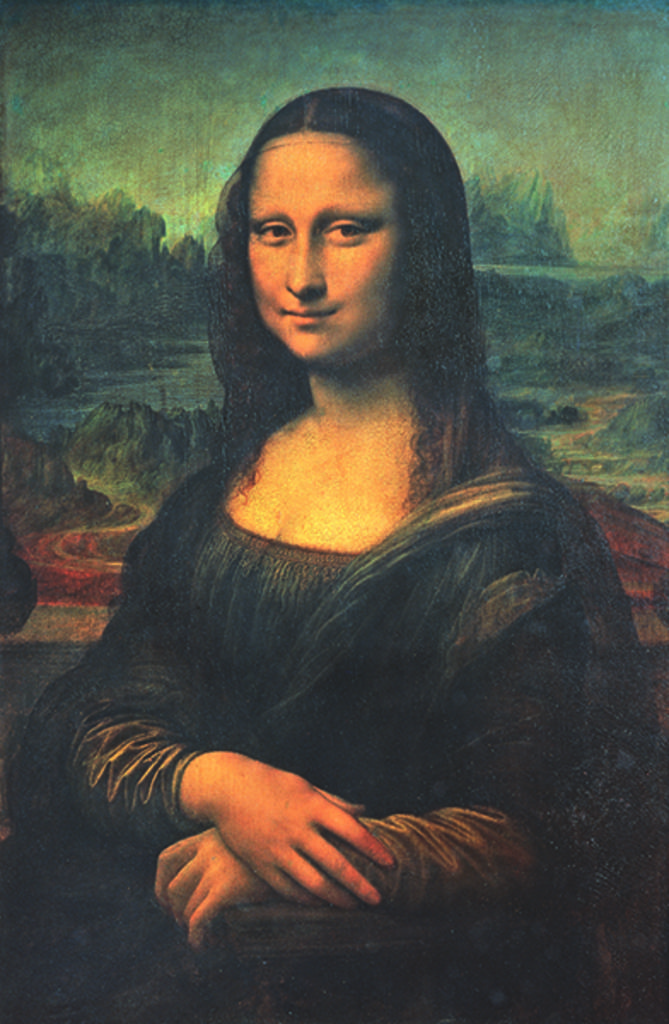What is the main subject of the image? The main subject of the image is a photo. What is depicted in the photo? The photo contains an image of a woman standing. What type of shirt is the woman wearing in the photo? There is no information about the woman's shirt in the image. What type of discussion is the woman having in the photo? There is no indication of a discussion in the photo; it only shows a woman standing. Is the woman coughing in the photo? There is no indication of the woman coughing in the photo; it only shows a woman standing. 